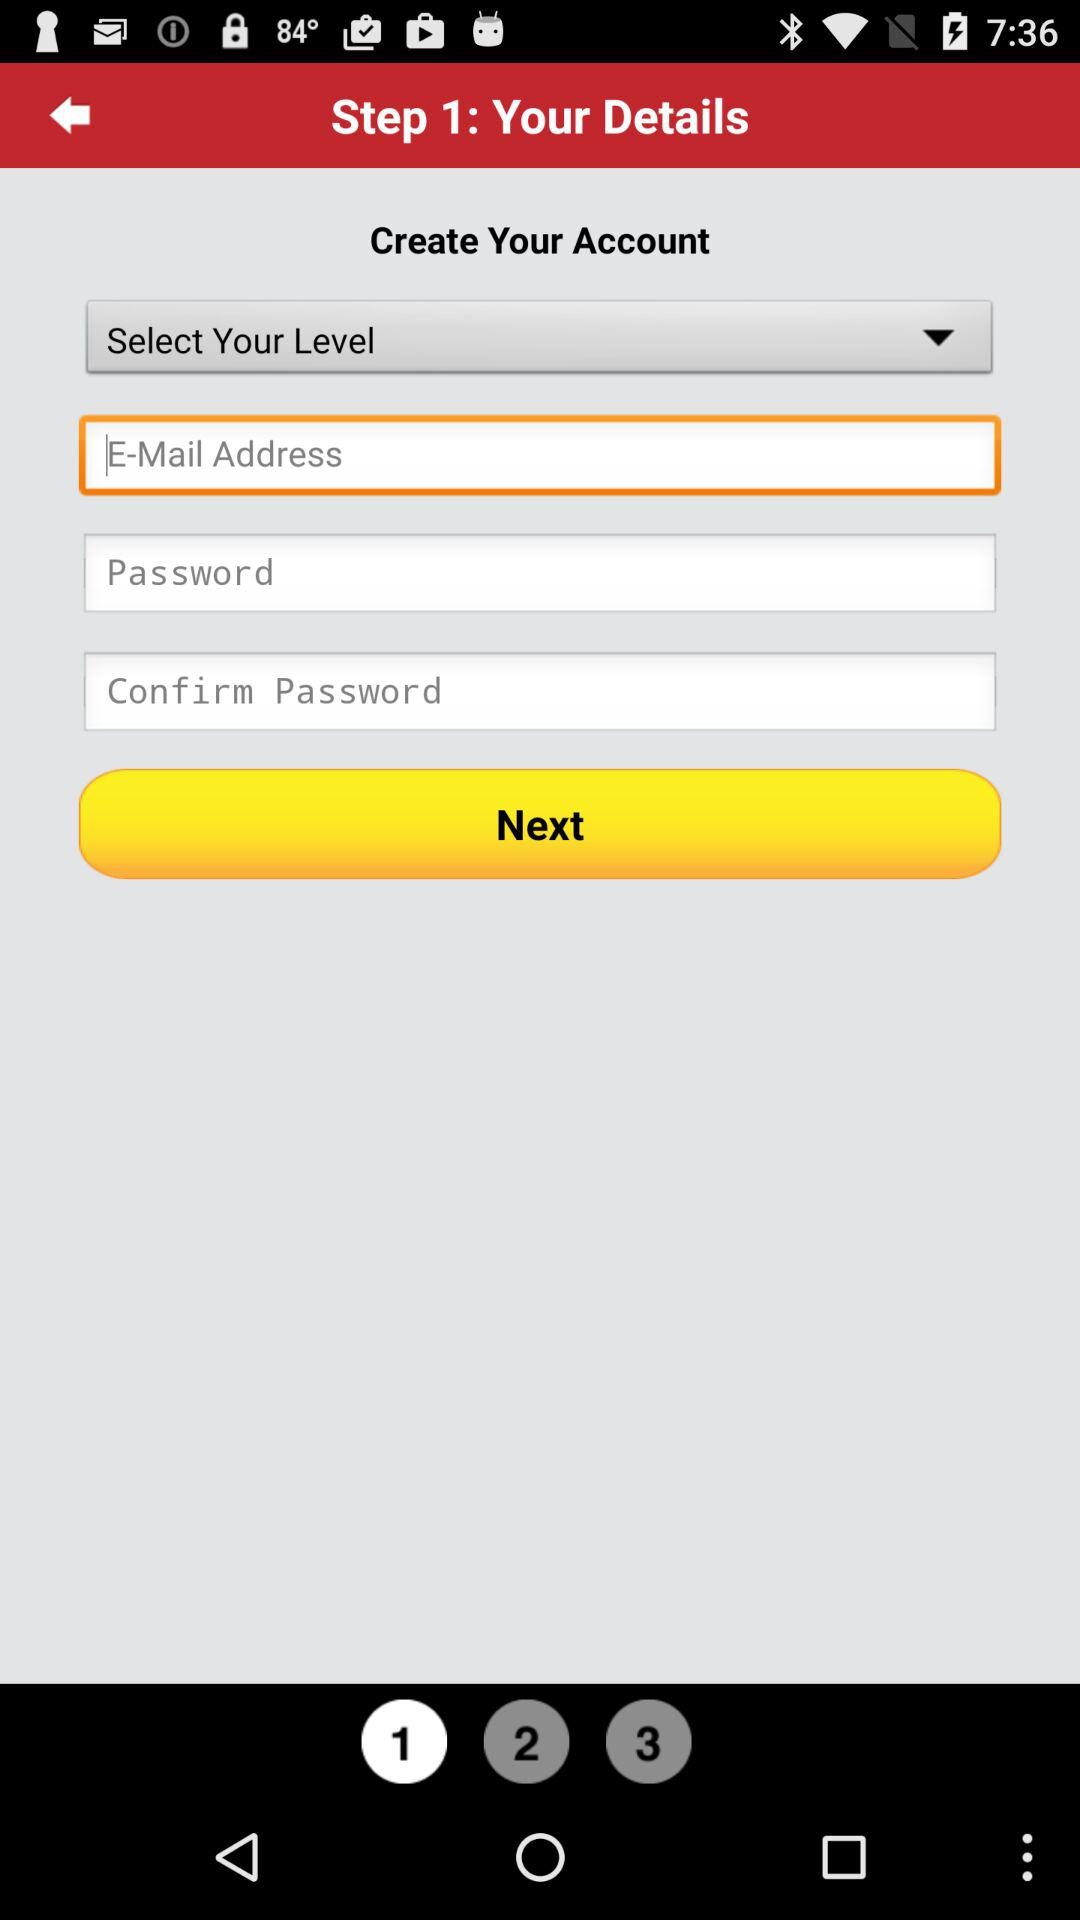At which step am I? You are at step 1. 